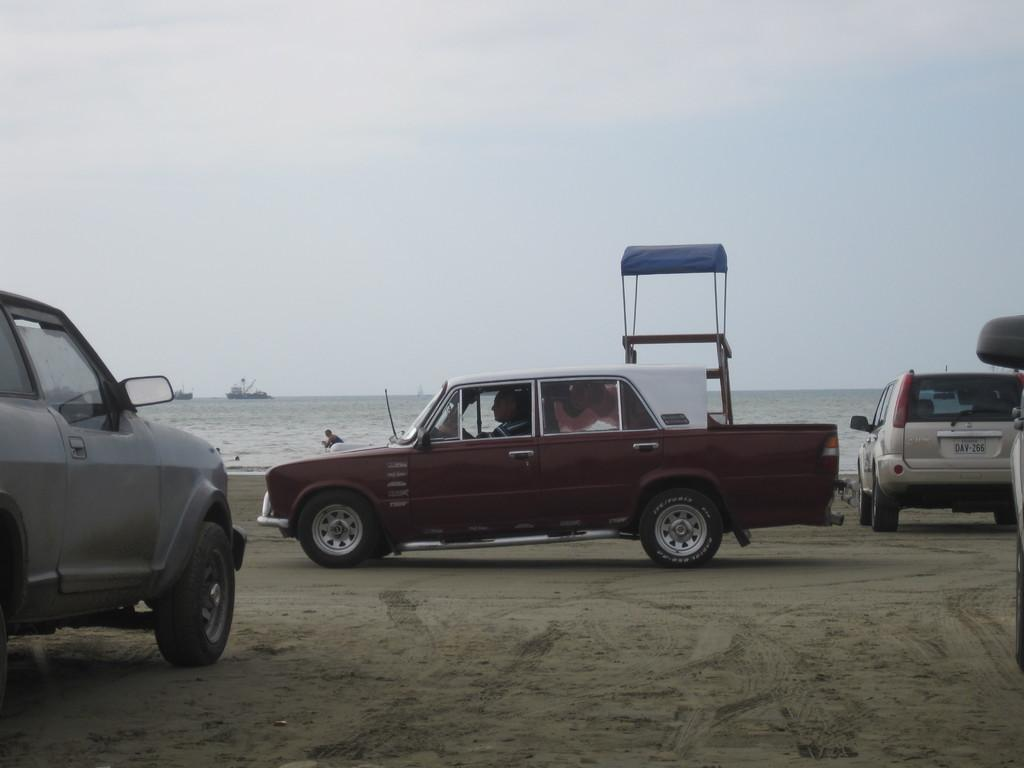What is the unusual surface on which the cars are parked in the image? The cars are parked on the sand in the image. What can be seen in the background of the image? The sky is plain and visible in the background of the image. What is floating on the water in the image? Ships are floating on the water in the image. What structure can be seen in the image? There is a stand in the image. What type of brick is being used to build the playground in the image? There is no playground or brick present in the image. What type of rifle can be seen in the hands of the person in the image? There is no person or rifle present in the image. 